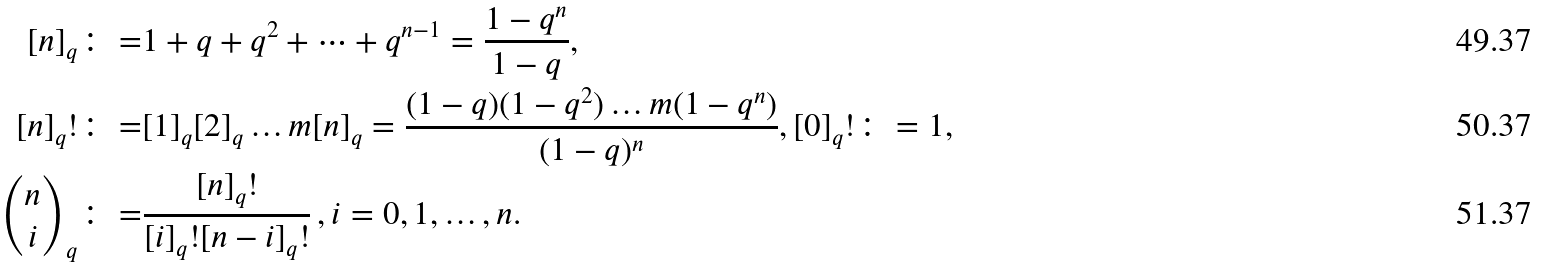<formula> <loc_0><loc_0><loc_500><loc_500>[ n ] _ { q } \colon = & 1 + q + q ^ { 2 } + \dots + q ^ { n - 1 } = \frac { 1 - q ^ { n } } { 1 - q } , \\ [ n ] _ { q } ! \colon = & [ 1 ] _ { q } [ 2 ] _ { q } \dots m [ n ] _ { q } = \frac { ( 1 - q ) ( 1 - q ^ { 2 } ) \dots m ( 1 - q ^ { n } ) } { ( 1 - q ) ^ { n } } , [ 0 ] _ { q } ! \colon = 1 , \\ { n \choose i } _ { q } \colon = & \frac { [ n ] _ { q } ! } { [ i ] _ { q } ! [ n - i ] _ { q } ! } \, , i = 0 , 1 , \dots , n .</formula> 